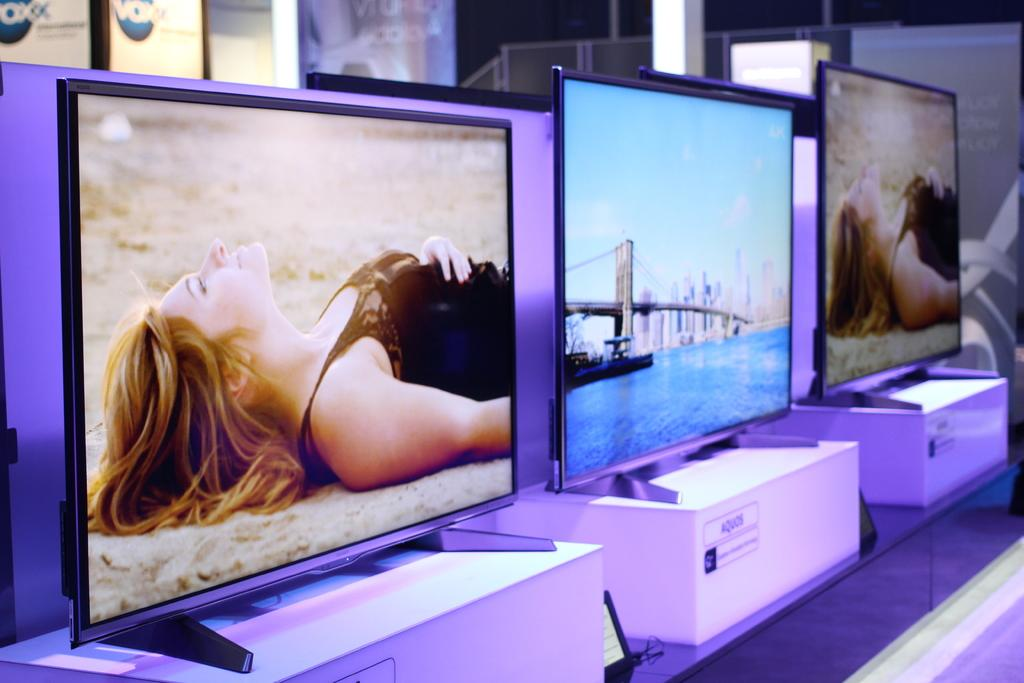<image>
Relay a brief, clear account of the picture shown. Several monitors are lined up in a row on boxes that are labeled Aquos. 